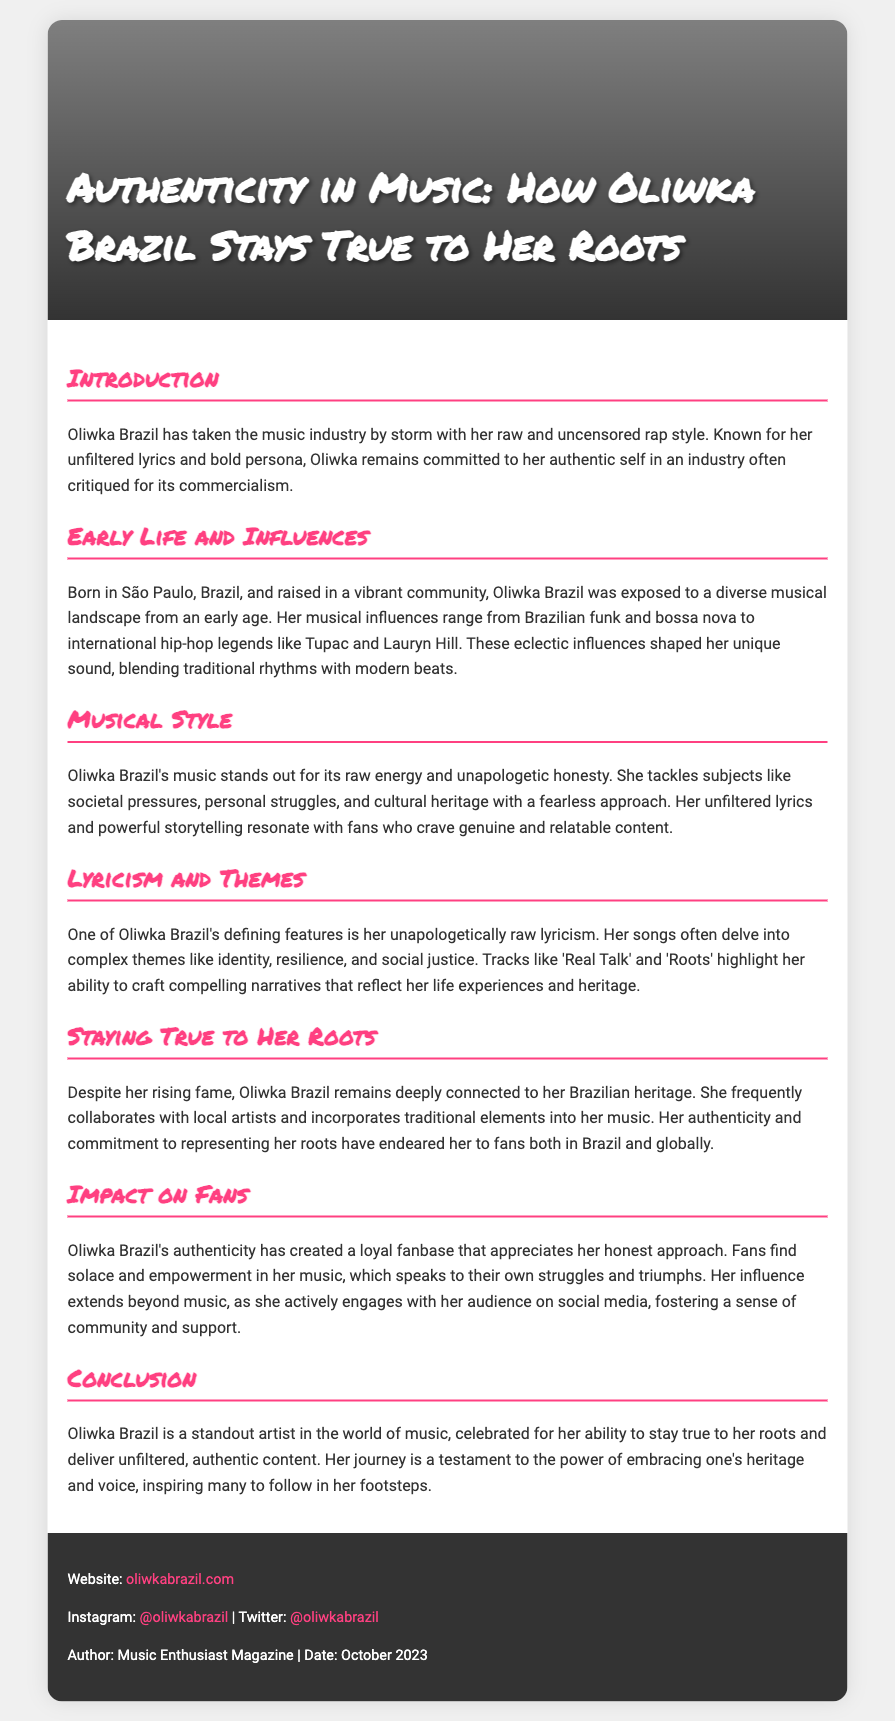What is the title of the Playbill? The title of the Playbill is prominently displayed at the top of the document, indicating the focus of the content.
Answer: Authenticity in Music: How Oliwka Brazil Stays True to Her Roots Where was Oliwka Brazil born? The document specifies her place of birth in the section about her early life and influences.
Answer: São Paulo What musical genres influence Oliwka Brazil? The document lists her various musical influences, highlighting the diversity in her sound.
Answer: Brazilian funk, bossa nova, hip-hop What themes are prevalent in her lyricism? The document describes the types of themes Oliwka tackles in her music, indicating her lyrical focus.
Answer: Identity, resilience, social justice How does Oliwka Brazil connect with her fans? The document outlines her approach to fan engagement, indicating her strategy for building a loyal audience.
Answer: Social media What is one of her notable songs? The document mentions specific songs that highlight her narrative style and themes.
Answer: Real Talk What does she incorporate into her music to stay true to her roots? The document discusses how she maintains her authenticity and cultural heritage in her work.
Answer: Traditional elements What is the relationship between her authenticity and her fanbase? The document explains the impact of her authentic style on the perception and loyalty of her fans.
Answer: Solace and empowerment What date was this document published? The footer of the Playbill includes the publication date of the content.
Answer: October 2023 